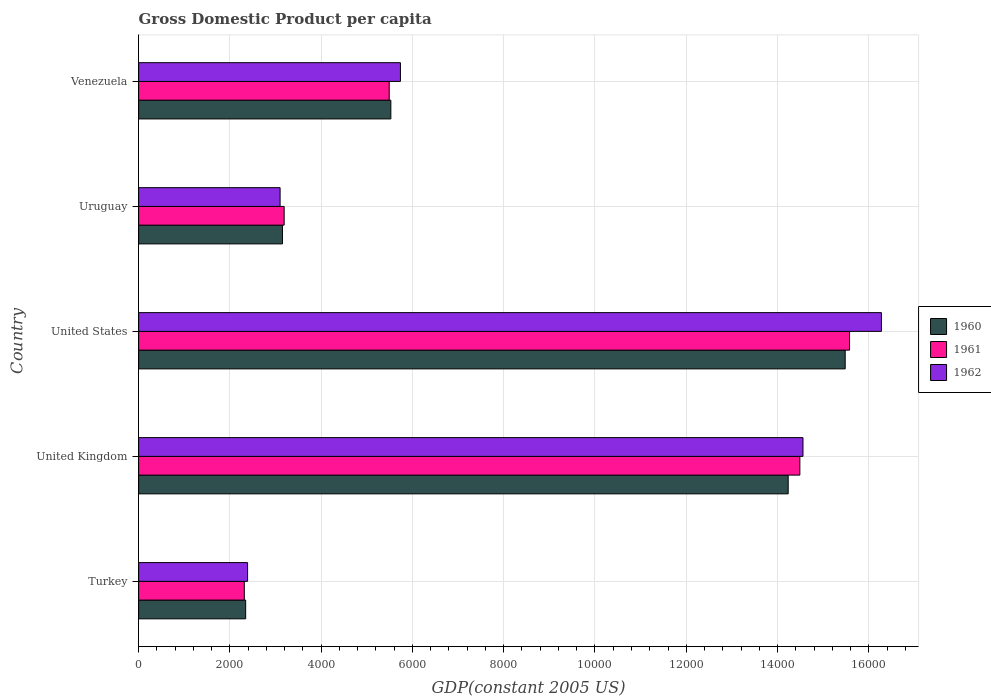Are the number of bars per tick equal to the number of legend labels?
Keep it short and to the point. Yes. Are the number of bars on each tick of the Y-axis equal?
Offer a very short reply. Yes. What is the label of the 4th group of bars from the top?
Offer a terse response. United Kingdom. What is the GDP per capita in 1960 in United States?
Ensure brevity in your answer.  1.55e+04. Across all countries, what is the maximum GDP per capita in 1961?
Give a very brief answer. 1.56e+04. Across all countries, what is the minimum GDP per capita in 1962?
Ensure brevity in your answer.  2387.4. In which country was the GDP per capita in 1961 maximum?
Provide a succinct answer. United States. What is the total GDP per capita in 1961 in the graph?
Give a very brief answer. 4.11e+04. What is the difference between the GDP per capita in 1960 in Turkey and that in Venezuela?
Keep it short and to the point. -3181.12. What is the difference between the GDP per capita in 1960 in United Kingdom and the GDP per capita in 1961 in Turkey?
Ensure brevity in your answer.  1.19e+04. What is the average GDP per capita in 1961 per country?
Keep it short and to the point. 8212.76. What is the difference between the GDP per capita in 1961 and GDP per capita in 1960 in United Kingdom?
Offer a very short reply. 255.71. In how many countries, is the GDP per capita in 1962 greater than 3600 US$?
Your answer should be compact. 3. What is the ratio of the GDP per capita in 1962 in Turkey to that in United States?
Your response must be concise. 0.15. Is the difference between the GDP per capita in 1961 in United States and Venezuela greater than the difference between the GDP per capita in 1960 in United States and Venezuela?
Your response must be concise. Yes. What is the difference between the highest and the second highest GDP per capita in 1960?
Your response must be concise. 1248.99. What is the difference between the highest and the lowest GDP per capita in 1962?
Keep it short and to the point. 1.39e+04. In how many countries, is the GDP per capita in 1962 greater than the average GDP per capita in 1962 taken over all countries?
Your answer should be compact. 2. Is it the case that in every country, the sum of the GDP per capita in 1961 and GDP per capita in 1962 is greater than the GDP per capita in 1960?
Offer a very short reply. Yes. What is the difference between two consecutive major ticks on the X-axis?
Offer a terse response. 2000. Does the graph contain grids?
Ensure brevity in your answer.  Yes. Where does the legend appear in the graph?
Give a very brief answer. Center right. How many legend labels are there?
Provide a succinct answer. 3. How are the legend labels stacked?
Your answer should be compact. Vertical. What is the title of the graph?
Your response must be concise. Gross Domestic Product per capita. Does "1974" appear as one of the legend labels in the graph?
Offer a very short reply. No. What is the label or title of the X-axis?
Provide a short and direct response. GDP(constant 2005 US). What is the GDP(constant 2005 US) of 1960 in Turkey?
Keep it short and to the point. 2345.64. What is the GDP(constant 2005 US) of 1961 in Turkey?
Your answer should be very brief. 2315.94. What is the GDP(constant 2005 US) of 1962 in Turkey?
Your answer should be very brief. 2387.4. What is the GDP(constant 2005 US) of 1960 in United Kingdom?
Provide a succinct answer. 1.42e+04. What is the GDP(constant 2005 US) in 1961 in United Kingdom?
Give a very brief answer. 1.45e+04. What is the GDP(constant 2005 US) in 1962 in United Kingdom?
Offer a very short reply. 1.46e+04. What is the GDP(constant 2005 US) in 1960 in United States?
Your answer should be compact. 1.55e+04. What is the GDP(constant 2005 US) of 1961 in United States?
Offer a terse response. 1.56e+04. What is the GDP(constant 2005 US) of 1962 in United States?
Provide a succinct answer. 1.63e+04. What is the GDP(constant 2005 US) in 1960 in Uruguay?
Your answer should be very brief. 3151.96. What is the GDP(constant 2005 US) in 1961 in Uruguay?
Your answer should be compact. 3189.04. What is the GDP(constant 2005 US) of 1962 in Uruguay?
Offer a very short reply. 3100.01. What is the GDP(constant 2005 US) of 1960 in Venezuela?
Make the answer very short. 5526.76. What is the GDP(constant 2005 US) in 1961 in Venezuela?
Offer a very short reply. 5491. What is the GDP(constant 2005 US) of 1962 in Venezuela?
Ensure brevity in your answer.  5736.57. Across all countries, what is the maximum GDP(constant 2005 US) of 1960?
Your response must be concise. 1.55e+04. Across all countries, what is the maximum GDP(constant 2005 US) of 1961?
Keep it short and to the point. 1.56e+04. Across all countries, what is the maximum GDP(constant 2005 US) in 1962?
Your answer should be very brief. 1.63e+04. Across all countries, what is the minimum GDP(constant 2005 US) of 1960?
Offer a terse response. 2345.64. Across all countries, what is the minimum GDP(constant 2005 US) of 1961?
Your answer should be very brief. 2315.94. Across all countries, what is the minimum GDP(constant 2005 US) in 1962?
Ensure brevity in your answer.  2387.4. What is the total GDP(constant 2005 US) in 1960 in the graph?
Keep it short and to the point. 4.07e+04. What is the total GDP(constant 2005 US) in 1961 in the graph?
Provide a succinct answer. 4.11e+04. What is the total GDP(constant 2005 US) of 1962 in the graph?
Your response must be concise. 4.21e+04. What is the difference between the GDP(constant 2005 US) in 1960 in Turkey and that in United Kingdom?
Your answer should be very brief. -1.19e+04. What is the difference between the GDP(constant 2005 US) of 1961 in Turkey and that in United Kingdom?
Keep it short and to the point. -1.22e+04. What is the difference between the GDP(constant 2005 US) in 1962 in Turkey and that in United Kingdom?
Your answer should be compact. -1.22e+04. What is the difference between the GDP(constant 2005 US) in 1960 in Turkey and that in United States?
Ensure brevity in your answer.  -1.31e+04. What is the difference between the GDP(constant 2005 US) in 1961 in Turkey and that in United States?
Give a very brief answer. -1.33e+04. What is the difference between the GDP(constant 2005 US) in 1962 in Turkey and that in United States?
Give a very brief answer. -1.39e+04. What is the difference between the GDP(constant 2005 US) in 1960 in Turkey and that in Uruguay?
Keep it short and to the point. -806.32. What is the difference between the GDP(constant 2005 US) of 1961 in Turkey and that in Uruguay?
Provide a short and direct response. -873.09. What is the difference between the GDP(constant 2005 US) in 1962 in Turkey and that in Uruguay?
Offer a terse response. -712.61. What is the difference between the GDP(constant 2005 US) of 1960 in Turkey and that in Venezuela?
Your answer should be compact. -3181.12. What is the difference between the GDP(constant 2005 US) in 1961 in Turkey and that in Venezuela?
Give a very brief answer. -3175.06. What is the difference between the GDP(constant 2005 US) of 1962 in Turkey and that in Venezuela?
Offer a very short reply. -3349.16. What is the difference between the GDP(constant 2005 US) in 1960 in United Kingdom and that in United States?
Give a very brief answer. -1248.99. What is the difference between the GDP(constant 2005 US) of 1961 in United Kingdom and that in United States?
Keep it short and to the point. -1088.98. What is the difference between the GDP(constant 2005 US) in 1962 in United Kingdom and that in United States?
Offer a very short reply. -1718.65. What is the difference between the GDP(constant 2005 US) in 1960 in United Kingdom and that in Uruguay?
Offer a very short reply. 1.11e+04. What is the difference between the GDP(constant 2005 US) in 1961 in United Kingdom and that in Uruguay?
Provide a succinct answer. 1.13e+04. What is the difference between the GDP(constant 2005 US) in 1962 in United Kingdom and that in Uruguay?
Keep it short and to the point. 1.15e+04. What is the difference between the GDP(constant 2005 US) of 1960 in United Kingdom and that in Venezuela?
Your answer should be very brief. 8706.96. What is the difference between the GDP(constant 2005 US) in 1961 in United Kingdom and that in Venezuela?
Your answer should be compact. 8998.42. What is the difference between the GDP(constant 2005 US) in 1962 in United Kingdom and that in Venezuela?
Your response must be concise. 8821.21. What is the difference between the GDP(constant 2005 US) of 1960 in United States and that in Uruguay?
Offer a terse response. 1.23e+04. What is the difference between the GDP(constant 2005 US) in 1961 in United States and that in Uruguay?
Offer a very short reply. 1.24e+04. What is the difference between the GDP(constant 2005 US) of 1962 in United States and that in Uruguay?
Provide a succinct answer. 1.32e+04. What is the difference between the GDP(constant 2005 US) in 1960 in United States and that in Venezuela?
Your answer should be very brief. 9955.94. What is the difference between the GDP(constant 2005 US) in 1961 in United States and that in Venezuela?
Your response must be concise. 1.01e+04. What is the difference between the GDP(constant 2005 US) of 1962 in United States and that in Venezuela?
Your answer should be very brief. 1.05e+04. What is the difference between the GDP(constant 2005 US) in 1960 in Uruguay and that in Venezuela?
Provide a succinct answer. -2374.8. What is the difference between the GDP(constant 2005 US) in 1961 in Uruguay and that in Venezuela?
Make the answer very short. -2301.97. What is the difference between the GDP(constant 2005 US) in 1962 in Uruguay and that in Venezuela?
Your response must be concise. -2636.56. What is the difference between the GDP(constant 2005 US) of 1960 in Turkey and the GDP(constant 2005 US) of 1961 in United Kingdom?
Ensure brevity in your answer.  -1.21e+04. What is the difference between the GDP(constant 2005 US) of 1960 in Turkey and the GDP(constant 2005 US) of 1962 in United Kingdom?
Your answer should be very brief. -1.22e+04. What is the difference between the GDP(constant 2005 US) of 1961 in Turkey and the GDP(constant 2005 US) of 1962 in United Kingdom?
Offer a terse response. -1.22e+04. What is the difference between the GDP(constant 2005 US) in 1960 in Turkey and the GDP(constant 2005 US) in 1961 in United States?
Provide a short and direct response. -1.32e+04. What is the difference between the GDP(constant 2005 US) of 1960 in Turkey and the GDP(constant 2005 US) of 1962 in United States?
Offer a very short reply. -1.39e+04. What is the difference between the GDP(constant 2005 US) in 1961 in Turkey and the GDP(constant 2005 US) in 1962 in United States?
Ensure brevity in your answer.  -1.40e+04. What is the difference between the GDP(constant 2005 US) in 1960 in Turkey and the GDP(constant 2005 US) in 1961 in Uruguay?
Keep it short and to the point. -843.39. What is the difference between the GDP(constant 2005 US) in 1960 in Turkey and the GDP(constant 2005 US) in 1962 in Uruguay?
Offer a very short reply. -754.37. What is the difference between the GDP(constant 2005 US) of 1961 in Turkey and the GDP(constant 2005 US) of 1962 in Uruguay?
Keep it short and to the point. -784.07. What is the difference between the GDP(constant 2005 US) in 1960 in Turkey and the GDP(constant 2005 US) in 1961 in Venezuela?
Offer a very short reply. -3145.36. What is the difference between the GDP(constant 2005 US) of 1960 in Turkey and the GDP(constant 2005 US) of 1962 in Venezuela?
Provide a succinct answer. -3390.92. What is the difference between the GDP(constant 2005 US) of 1961 in Turkey and the GDP(constant 2005 US) of 1962 in Venezuela?
Provide a short and direct response. -3420.63. What is the difference between the GDP(constant 2005 US) in 1960 in United Kingdom and the GDP(constant 2005 US) in 1961 in United States?
Make the answer very short. -1344.69. What is the difference between the GDP(constant 2005 US) in 1960 in United Kingdom and the GDP(constant 2005 US) in 1962 in United States?
Offer a very short reply. -2042.71. What is the difference between the GDP(constant 2005 US) of 1961 in United Kingdom and the GDP(constant 2005 US) of 1962 in United States?
Your answer should be compact. -1787. What is the difference between the GDP(constant 2005 US) of 1960 in United Kingdom and the GDP(constant 2005 US) of 1961 in Uruguay?
Your answer should be very brief. 1.10e+04. What is the difference between the GDP(constant 2005 US) in 1960 in United Kingdom and the GDP(constant 2005 US) in 1962 in Uruguay?
Keep it short and to the point. 1.11e+04. What is the difference between the GDP(constant 2005 US) of 1961 in United Kingdom and the GDP(constant 2005 US) of 1962 in Uruguay?
Your answer should be very brief. 1.14e+04. What is the difference between the GDP(constant 2005 US) of 1960 in United Kingdom and the GDP(constant 2005 US) of 1961 in Venezuela?
Provide a short and direct response. 8742.71. What is the difference between the GDP(constant 2005 US) in 1960 in United Kingdom and the GDP(constant 2005 US) in 1962 in Venezuela?
Ensure brevity in your answer.  8497.15. What is the difference between the GDP(constant 2005 US) in 1961 in United Kingdom and the GDP(constant 2005 US) in 1962 in Venezuela?
Provide a succinct answer. 8752.86. What is the difference between the GDP(constant 2005 US) in 1960 in United States and the GDP(constant 2005 US) in 1961 in Uruguay?
Make the answer very short. 1.23e+04. What is the difference between the GDP(constant 2005 US) in 1960 in United States and the GDP(constant 2005 US) in 1962 in Uruguay?
Your answer should be compact. 1.24e+04. What is the difference between the GDP(constant 2005 US) in 1961 in United States and the GDP(constant 2005 US) in 1962 in Uruguay?
Provide a succinct answer. 1.25e+04. What is the difference between the GDP(constant 2005 US) in 1960 in United States and the GDP(constant 2005 US) in 1961 in Venezuela?
Offer a terse response. 9991.7. What is the difference between the GDP(constant 2005 US) in 1960 in United States and the GDP(constant 2005 US) in 1962 in Venezuela?
Offer a terse response. 9746.14. What is the difference between the GDP(constant 2005 US) of 1961 in United States and the GDP(constant 2005 US) of 1962 in Venezuela?
Make the answer very short. 9841.84. What is the difference between the GDP(constant 2005 US) of 1960 in Uruguay and the GDP(constant 2005 US) of 1961 in Venezuela?
Give a very brief answer. -2339.04. What is the difference between the GDP(constant 2005 US) of 1960 in Uruguay and the GDP(constant 2005 US) of 1962 in Venezuela?
Provide a short and direct response. -2584.61. What is the difference between the GDP(constant 2005 US) of 1961 in Uruguay and the GDP(constant 2005 US) of 1962 in Venezuela?
Your answer should be compact. -2547.53. What is the average GDP(constant 2005 US) of 1960 per country?
Offer a very short reply. 8148.16. What is the average GDP(constant 2005 US) of 1961 per country?
Offer a terse response. 8212.76. What is the average GDP(constant 2005 US) of 1962 per country?
Ensure brevity in your answer.  8411.64. What is the difference between the GDP(constant 2005 US) of 1960 and GDP(constant 2005 US) of 1961 in Turkey?
Your response must be concise. 29.7. What is the difference between the GDP(constant 2005 US) in 1960 and GDP(constant 2005 US) in 1962 in Turkey?
Your response must be concise. -41.76. What is the difference between the GDP(constant 2005 US) in 1961 and GDP(constant 2005 US) in 1962 in Turkey?
Keep it short and to the point. -71.46. What is the difference between the GDP(constant 2005 US) of 1960 and GDP(constant 2005 US) of 1961 in United Kingdom?
Give a very brief answer. -255.71. What is the difference between the GDP(constant 2005 US) of 1960 and GDP(constant 2005 US) of 1962 in United Kingdom?
Your answer should be compact. -324.06. What is the difference between the GDP(constant 2005 US) of 1961 and GDP(constant 2005 US) of 1962 in United Kingdom?
Make the answer very short. -68.35. What is the difference between the GDP(constant 2005 US) of 1960 and GDP(constant 2005 US) of 1961 in United States?
Your answer should be compact. -95.7. What is the difference between the GDP(constant 2005 US) of 1960 and GDP(constant 2005 US) of 1962 in United States?
Keep it short and to the point. -793.72. What is the difference between the GDP(constant 2005 US) in 1961 and GDP(constant 2005 US) in 1962 in United States?
Your answer should be compact. -698.02. What is the difference between the GDP(constant 2005 US) in 1960 and GDP(constant 2005 US) in 1961 in Uruguay?
Give a very brief answer. -37.08. What is the difference between the GDP(constant 2005 US) of 1960 and GDP(constant 2005 US) of 1962 in Uruguay?
Your answer should be compact. 51.95. What is the difference between the GDP(constant 2005 US) of 1961 and GDP(constant 2005 US) of 1962 in Uruguay?
Offer a terse response. 89.02. What is the difference between the GDP(constant 2005 US) in 1960 and GDP(constant 2005 US) in 1961 in Venezuela?
Keep it short and to the point. 35.76. What is the difference between the GDP(constant 2005 US) of 1960 and GDP(constant 2005 US) of 1962 in Venezuela?
Your response must be concise. -209.8. What is the difference between the GDP(constant 2005 US) of 1961 and GDP(constant 2005 US) of 1962 in Venezuela?
Your answer should be very brief. -245.56. What is the ratio of the GDP(constant 2005 US) in 1960 in Turkey to that in United Kingdom?
Your response must be concise. 0.16. What is the ratio of the GDP(constant 2005 US) of 1961 in Turkey to that in United Kingdom?
Your response must be concise. 0.16. What is the ratio of the GDP(constant 2005 US) of 1962 in Turkey to that in United Kingdom?
Provide a succinct answer. 0.16. What is the ratio of the GDP(constant 2005 US) in 1960 in Turkey to that in United States?
Your answer should be very brief. 0.15. What is the ratio of the GDP(constant 2005 US) in 1961 in Turkey to that in United States?
Provide a succinct answer. 0.15. What is the ratio of the GDP(constant 2005 US) in 1962 in Turkey to that in United States?
Your response must be concise. 0.15. What is the ratio of the GDP(constant 2005 US) in 1960 in Turkey to that in Uruguay?
Your response must be concise. 0.74. What is the ratio of the GDP(constant 2005 US) in 1961 in Turkey to that in Uruguay?
Your response must be concise. 0.73. What is the ratio of the GDP(constant 2005 US) in 1962 in Turkey to that in Uruguay?
Offer a very short reply. 0.77. What is the ratio of the GDP(constant 2005 US) of 1960 in Turkey to that in Venezuela?
Ensure brevity in your answer.  0.42. What is the ratio of the GDP(constant 2005 US) in 1961 in Turkey to that in Venezuela?
Give a very brief answer. 0.42. What is the ratio of the GDP(constant 2005 US) of 1962 in Turkey to that in Venezuela?
Your answer should be compact. 0.42. What is the ratio of the GDP(constant 2005 US) of 1960 in United Kingdom to that in United States?
Make the answer very short. 0.92. What is the ratio of the GDP(constant 2005 US) in 1961 in United Kingdom to that in United States?
Ensure brevity in your answer.  0.93. What is the ratio of the GDP(constant 2005 US) in 1962 in United Kingdom to that in United States?
Your answer should be compact. 0.89. What is the ratio of the GDP(constant 2005 US) in 1960 in United Kingdom to that in Uruguay?
Ensure brevity in your answer.  4.52. What is the ratio of the GDP(constant 2005 US) in 1961 in United Kingdom to that in Uruguay?
Provide a succinct answer. 4.54. What is the ratio of the GDP(constant 2005 US) of 1962 in United Kingdom to that in Uruguay?
Provide a short and direct response. 4.7. What is the ratio of the GDP(constant 2005 US) in 1960 in United Kingdom to that in Venezuela?
Ensure brevity in your answer.  2.58. What is the ratio of the GDP(constant 2005 US) in 1961 in United Kingdom to that in Venezuela?
Provide a succinct answer. 2.64. What is the ratio of the GDP(constant 2005 US) in 1962 in United Kingdom to that in Venezuela?
Your answer should be very brief. 2.54. What is the ratio of the GDP(constant 2005 US) of 1960 in United States to that in Uruguay?
Your answer should be compact. 4.91. What is the ratio of the GDP(constant 2005 US) in 1961 in United States to that in Uruguay?
Offer a terse response. 4.88. What is the ratio of the GDP(constant 2005 US) in 1962 in United States to that in Uruguay?
Your response must be concise. 5.25. What is the ratio of the GDP(constant 2005 US) of 1960 in United States to that in Venezuela?
Offer a very short reply. 2.8. What is the ratio of the GDP(constant 2005 US) in 1961 in United States to that in Venezuela?
Offer a very short reply. 2.84. What is the ratio of the GDP(constant 2005 US) in 1962 in United States to that in Venezuela?
Give a very brief answer. 2.84. What is the ratio of the GDP(constant 2005 US) in 1960 in Uruguay to that in Venezuela?
Make the answer very short. 0.57. What is the ratio of the GDP(constant 2005 US) in 1961 in Uruguay to that in Venezuela?
Provide a succinct answer. 0.58. What is the ratio of the GDP(constant 2005 US) in 1962 in Uruguay to that in Venezuela?
Your answer should be compact. 0.54. What is the difference between the highest and the second highest GDP(constant 2005 US) in 1960?
Provide a succinct answer. 1248.99. What is the difference between the highest and the second highest GDP(constant 2005 US) in 1961?
Give a very brief answer. 1088.98. What is the difference between the highest and the second highest GDP(constant 2005 US) in 1962?
Provide a succinct answer. 1718.65. What is the difference between the highest and the lowest GDP(constant 2005 US) in 1960?
Your answer should be compact. 1.31e+04. What is the difference between the highest and the lowest GDP(constant 2005 US) of 1961?
Your answer should be compact. 1.33e+04. What is the difference between the highest and the lowest GDP(constant 2005 US) of 1962?
Make the answer very short. 1.39e+04. 